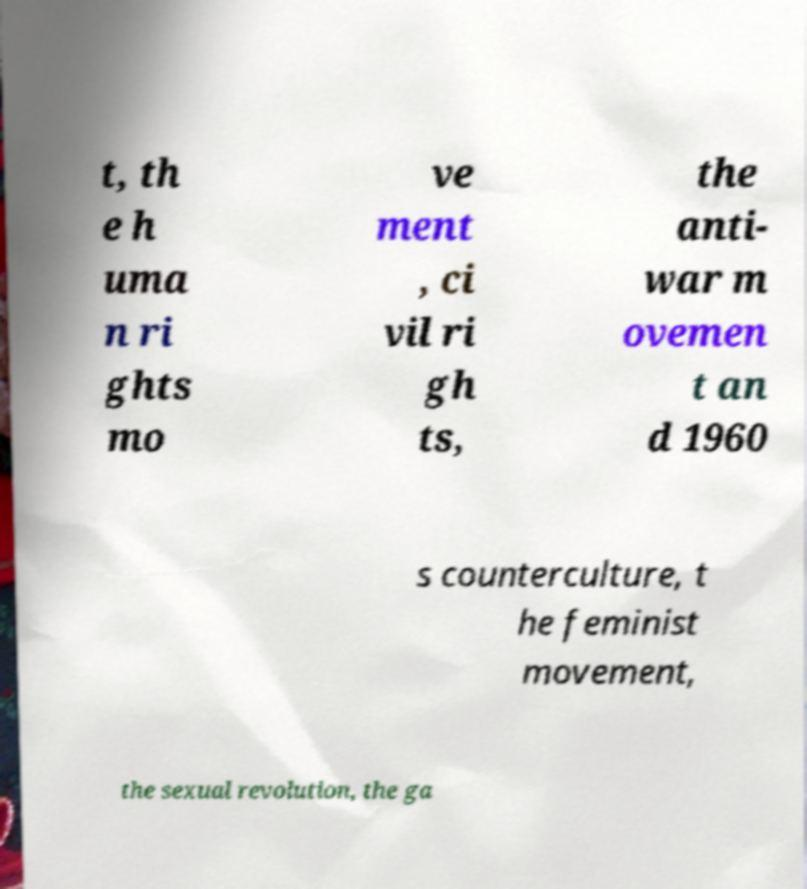Can you read and provide the text displayed in the image?This photo seems to have some interesting text. Can you extract and type it out for me? t, th e h uma n ri ghts mo ve ment , ci vil ri gh ts, the anti- war m ovemen t an d 1960 s counterculture, t he feminist movement, the sexual revolution, the ga 